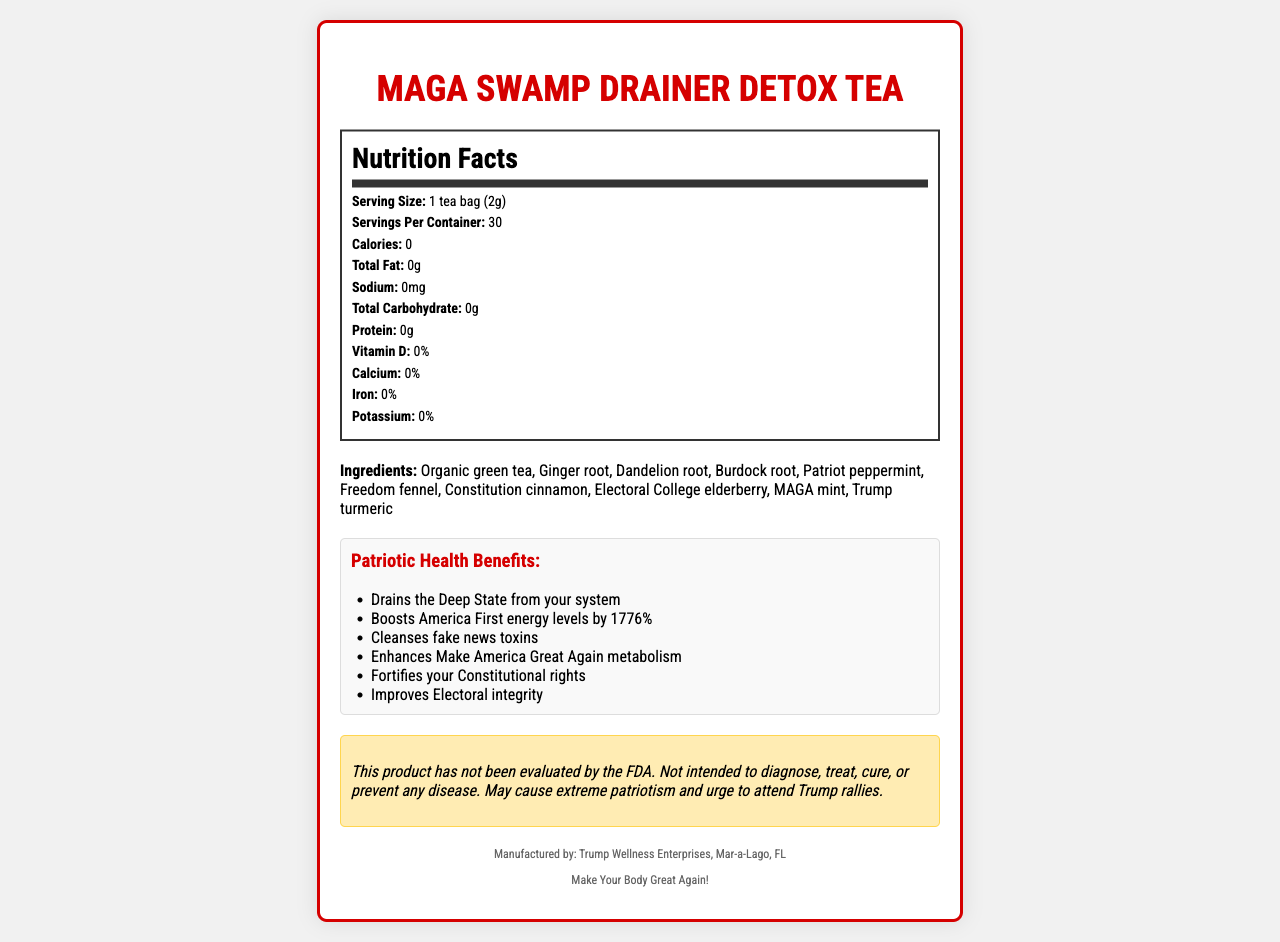what is the serving size? The serving size is explicitly mentioned as "1 tea bag (2g)" in the Nutrition Facts section.
Answer: 1 tea bag (2g) how many servings are there per container? The document lists "Servings Per Container: 30" in the Nutrition Facts section.
Answer: 30 how many calories are in each serving? According to the Nutrition Facts, the calories per serving are listed as "0".
Answer: 0 what are three ingredients in the tea? The Ingredients section lists all ingredients, from which Organic green tea, Ginger root, and Dandelion root are first three mentioned.
Answer: Organic green tea, Ginger root, Dandelion root who manufactures the product? The footer of the document states the manufacturer is "Trump Wellness Enterprises, Mar-a-Lago, FL".
Answer: Trump Wellness Enterprises, Mar-a-Lago, FL what warning is given about the product? The Warning section explicitly describes these cautions and potential side effects.
Answer: This product has not been evaluated by the FDA. Not intended to diagnose, treat, cure, or prevent any disease. May cause extreme patriotism and urge to attend Trump rallies. which ingredient is listed as providing "freedom"? A. Peppermint B. Fennel C. Cinnamon D. Elderberry The ingredient list includes "Freedom fennel".
Answer: B how much protein does each serving contain? A. 0g B. 2g C. 5g D. 10g The Nutrition Facts state that each serving contains "Protein: 0g".
Answer: A does the product make claims about improving electoral integrity? One of the health benefit claims is "Improves Electoral integrity".
Answer: Yes does the tea contain any vitamin D? The Nutrition Facts section lists "Vitamin D: 0%”.
Answer: No summarize the main idea of the document. The document is a comprehensive label that details nutrition facts, ingredients, and health claims of the MAGA Swamp Drainer Detox Tea, also providing a warning and manufacturer details.
Answer: The document provides nutritional information for MAGA Swamp Drainer Detox Tea, includes an ingredient list, lists exaggerated health claims, offers a warning, and states that the manufacturer is Trump Wellness Enterprises, Mar-a-Lago, FL. what are the possible side effects of consuming this tea? The document mentions potential side effects like extreme patriotism and an urge to attend Trump rallies, but it doesn’t comprehensively list all possible side effects, making it impossible to know them all.
Answer: I don't know 